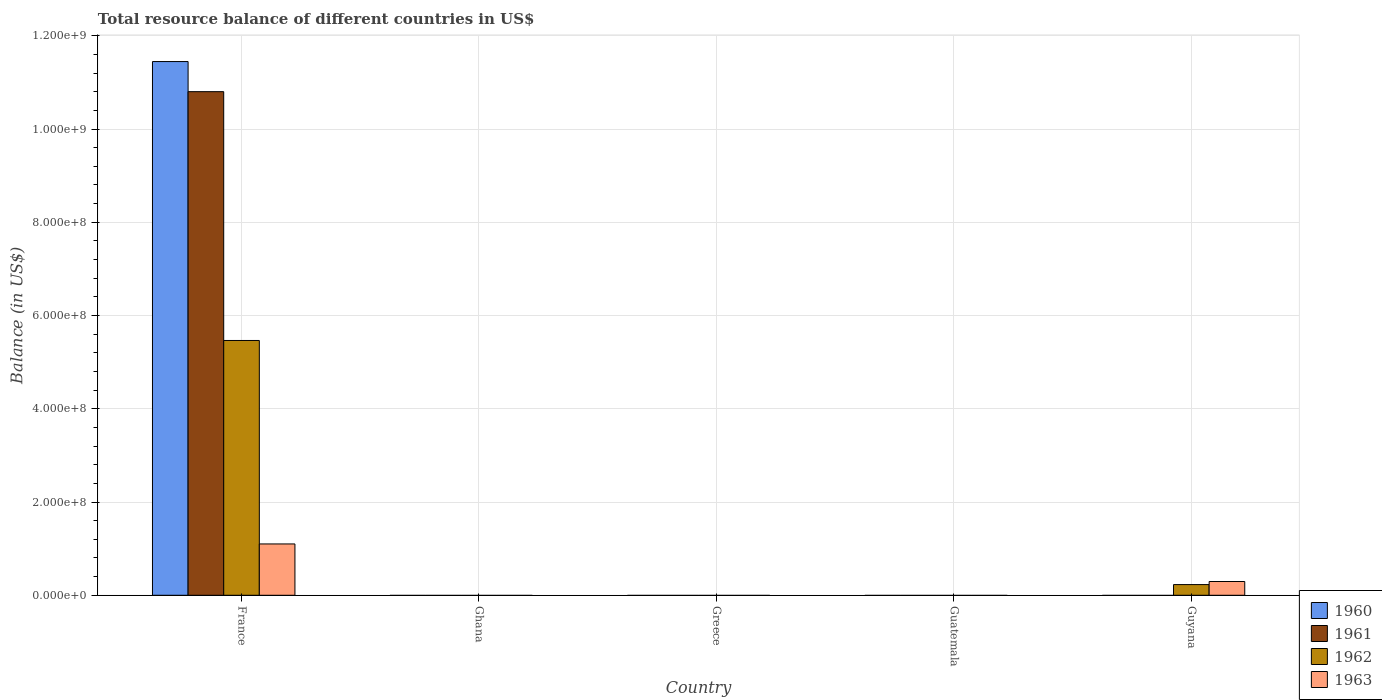Are the number of bars on each tick of the X-axis equal?
Provide a short and direct response. No. How many bars are there on the 1st tick from the left?
Your response must be concise. 4. How many bars are there on the 3rd tick from the right?
Keep it short and to the point. 0. What is the label of the 5th group of bars from the left?
Give a very brief answer. Guyana. In how many cases, is the number of bars for a given country not equal to the number of legend labels?
Provide a short and direct response. 4. Across all countries, what is the maximum total resource balance in 1962?
Keep it short and to the point. 5.46e+08. Across all countries, what is the minimum total resource balance in 1960?
Your answer should be compact. 0. In which country was the total resource balance in 1963 maximum?
Provide a succinct answer. France. What is the total total resource balance in 1960 in the graph?
Ensure brevity in your answer.  1.14e+09. What is the difference between the total resource balance in 1962 in France and that in Guyana?
Your answer should be compact. 5.24e+08. What is the difference between the total resource balance in 1962 in Guatemala and the total resource balance in 1963 in Guyana?
Give a very brief answer. -2.95e+07. What is the average total resource balance in 1961 per country?
Offer a terse response. 2.16e+08. What is the difference between the total resource balance of/in 1960 and total resource balance of/in 1963 in France?
Your response must be concise. 1.03e+09. In how many countries, is the total resource balance in 1962 greater than 240000000 US$?
Provide a short and direct response. 1. What is the difference between the highest and the lowest total resource balance in 1961?
Make the answer very short. 1.08e+09. In how many countries, is the total resource balance in 1961 greater than the average total resource balance in 1961 taken over all countries?
Offer a terse response. 1. How many bars are there?
Your response must be concise. 6. What is the difference between two consecutive major ticks on the Y-axis?
Ensure brevity in your answer.  2.00e+08. Are the values on the major ticks of Y-axis written in scientific E-notation?
Provide a short and direct response. Yes. Does the graph contain grids?
Make the answer very short. Yes. How many legend labels are there?
Provide a succinct answer. 4. How are the legend labels stacked?
Give a very brief answer. Vertical. What is the title of the graph?
Provide a succinct answer. Total resource balance of different countries in US$. What is the label or title of the X-axis?
Your answer should be compact. Country. What is the label or title of the Y-axis?
Offer a very short reply. Balance (in US$). What is the Balance (in US$) of 1960 in France?
Your answer should be compact. 1.14e+09. What is the Balance (in US$) of 1961 in France?
Your response must be concise. 1.08e+09. What is the Balance (in US$) in 1962 in France?
Give a very brief answer. 5.46e+08. What is the Balance (in US$) in 1963 in France?
Offer a very short reply. 1.10e+08. What is the Balance (in US$) in 1960 in Ghana?
Your answer should be very brief. 0. What is the Balance (in US$) of 1962 in Ghana?
Offer a terse response. 0. What is the Balance (in US$) of 1962 in Greece?
Ensure brevity in your answer.  0. What is the Balance (in US$) in 1960 in Guatemala?
Keep it short and to the point. 0. What is the Balance (in US$) in 1962 in Guatemala?
Provide a short and direct response. 0. What is the Balance (in US$) in 1961 in Guyana?
Make the answer very short. 0. What is the Balance (in US$) in 1962 in Guyana?
Offer a very short reply. 2.29e+07. What is the Balance (in US$) in 1963 in Guyana?
Your answer should be compact. 2.95e+07. Across all countries, what is the maximum Balance (in US$) of 1960?
Your answer should be very brief. 1.14e+09. Across all countries, what is the maximum Balance (in US$) in 1961?
Your answer should be compact. 1.08e+09. Across all countries, what is the maximum Balance (in US$) in 1962?
Give a very brief answer. 5.46e+08. Across all countries, what is the maximum Balance (in US$) of 1963?
Your answer should be very brief. 1.10e+08. Across all countries, what is the minimum Balance (in US$) in 1960?
Give a very brief answer. 0. Across all countries, what is the minimum Balance (in US$) in 1963?
Your response must be concise. 0. What is the total Balance (in US$) in 1960 in the graph?
Your answer should be very brief. 1.14e+09. What is the total Balance (in US$) of 1961 in the graph?
Your answer should be very brief. 1.08e+09. What is the total Balance (in US$) of 1962 in the graph?
Your answer should be compact. 5.69e+08. What is the total Balance (in US$) of 1963 in the graph?
Give a very brief answer. 1.40e+08. What is the difference between the Balance (in US$) in 1962 in France and that in Guyana?
Offer a terse response. 5.24e+08. What is the difference between the Balance (in US$) of 1963 in France and that in Guyana?
Your response must be concise. 8.06e+07. What is the difference between the Balance (in US$) of 1960 in France and the Balance (in US$) of 1962 in Guyana?
Make the answer very short. 1.12e+09. What is the difference between the Balance (in US$) in 1960 in France and the Balance (in US$) in 1963 in Guyana?
Give a very brief answer. 1.12e+09. What is the difference between the Balance (in US$) in 1961 in France and the Balance (in US$) in 1962 in Guyana?
Ensure brevity in your answer.  1.06e+09. What is the difference between the Balance (in US$) in 1961 in France and the Balance (in US$) in 1963 in Guyana?
Your answer should be very brief. 1.05e+09. What is the difference between the Balance (in US$) in 1962 in France and the Balance (in US$) in 1963 in Guyana?
Ensure brevity in your answer.  5.17e+08. What is the average Balance (in US$) in 1960 per country?
Your response must be concise. 2.29e+08. What is the average Balance (in US$) of 1961 per country?
Provide a short and direct response. 2.16e+08. What is the average Balance (in US$) of 1962 per country?
Offer a terse response. 1.14e+08. What is the average Balance (in US$) of 1963 per country?
Provide a succinct answer. 2.79e+07. What is the difference between the Balance (in US$) of 1960 and Balance (in US$) of 1961 in France?
Provide a short and direct response. 6.46e+07. What is the difference between the Balance (in US$) in 1960 and Balance (in US$) in 1962 in France?
Your response must be concise. 5.98e+08. What is the difference between the Balance (in US$) of 1960 and Balance (in US$) of 1963 in France?
Offer a terse response. 1.03e+09. What is the difference between the Balance (in US$) of 1961 and Balance (in US$) of 1962 in France?
Provide a succinct answer. 5.34e+08. What is the difference between the Balance (in US$) in 1961 and Balance (in US$) in 1963 in France?
Keep it short and to the point. 9.70e+08. What is the difference between the Balance (in US$) in 1962 and Balance (in US$) in 1963 in France?
Provide a succinct answer. 4.36e+08. What is the difference between the Balance (in US$) of 1962 and Balance (in US$) of 1963 in Guyana?
Your answer should be very brief. -6.59e+06. What is the ratio of the Balance (in US$) of 1962 in France to that in Guyana?
Offer a terse response. 23.84. What is the ratio of the Balance (in US$) in 1963 in France to that in Guyana?
Your answer should be compact. 3.73. What is the difference between the highest and the lowest Balance (in US$) in 1960?
Keep it short and to the point. 1.14e+09. What is the difference between the highest and the lowest Balance (in US$) of 1961?
Offer a terse response. 1.08e+09. What is the difference between the highest and the lowest Balance (in US$) of 1962?
Your answer should be very brief. 5.46e+08. What is the difference between the highest and the lowest Balance (in US$) in 1963?
Ensure brevity in your answer.  1.10e+08. 